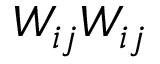Convert formula to latex. <formula><loc_0><loc_0><loc_500><loc_500>W _ { i j } W _ { i j }</formula> 